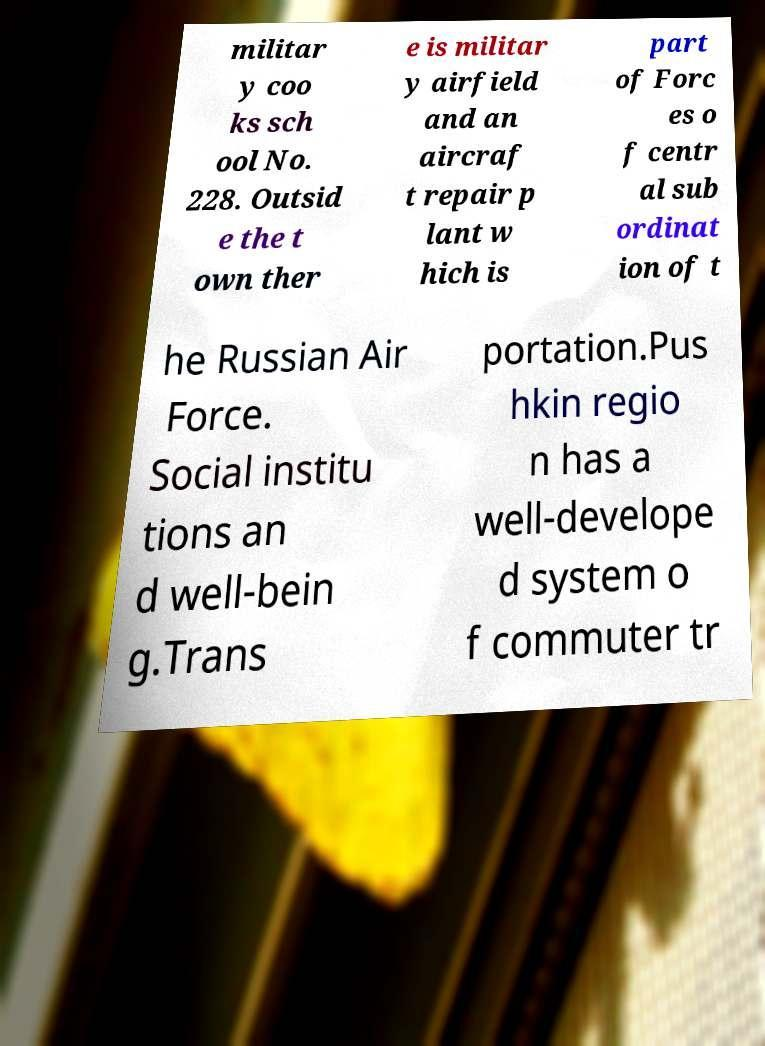Can you accurately transcribe the text from the provided image for me? militar y coo ks sch ool No. 228. Outsid e the t own ther e is militar y airfield and an aircraf t repair p lant w hich is part of Forc es o f centr al sub ordinat ion of t he Russian Air Force. Social institu tions an d well-bein g.Trans portation.Pus hkin regio n has a well-develope d system o f commuter tr 